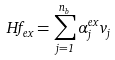Convert formula to latex. <formula><loc_0><loc_0><loc_500><loc_500>H f _ { e x } = \sum _ { j = 1 } ^ { n _ { b } } \alpha _ { j } ^ { e x } v _ { j }</formula> 